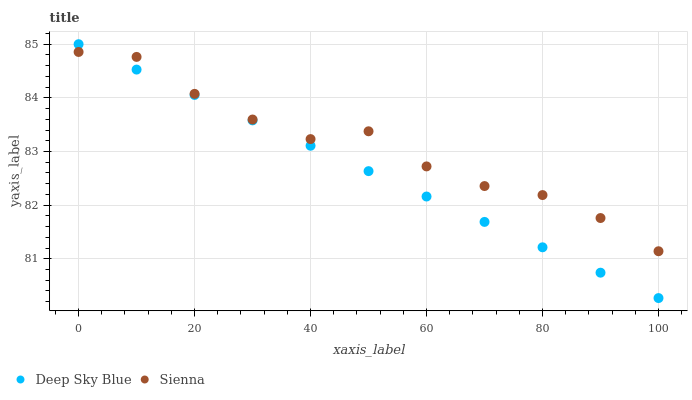Does Deep Sky Blue have the minimum area under the curve?
Answer yes or no. Yes. Does Sienna have the maximum area under the curve?
Answer yes or no. Yes. Does Deep Sky Blue have the maximum area under the curve?
Answer yes or no. No. Is Deep Sky Blue the smoothest?
Answer yes or no. Yes. Is Sienna the roughest?
Answer yes or no. Yes. Is Deep Sky Blue the roughest?
Answer yes or no. No. Does Deep Sky Blue have the lowest value?
Answer yes or no. Yes. Does Deep Sky Blue have the highest value?
Answer yes or no. Yes. Does Sienna intersect Deep Sky Blue?
Answer yes or no. Yes. Is Sienna less than Deep Sky Blue?
Answer yes or no. No. Is Sienna greater than Deep Sky Blue?
Answer yes or no. No. 